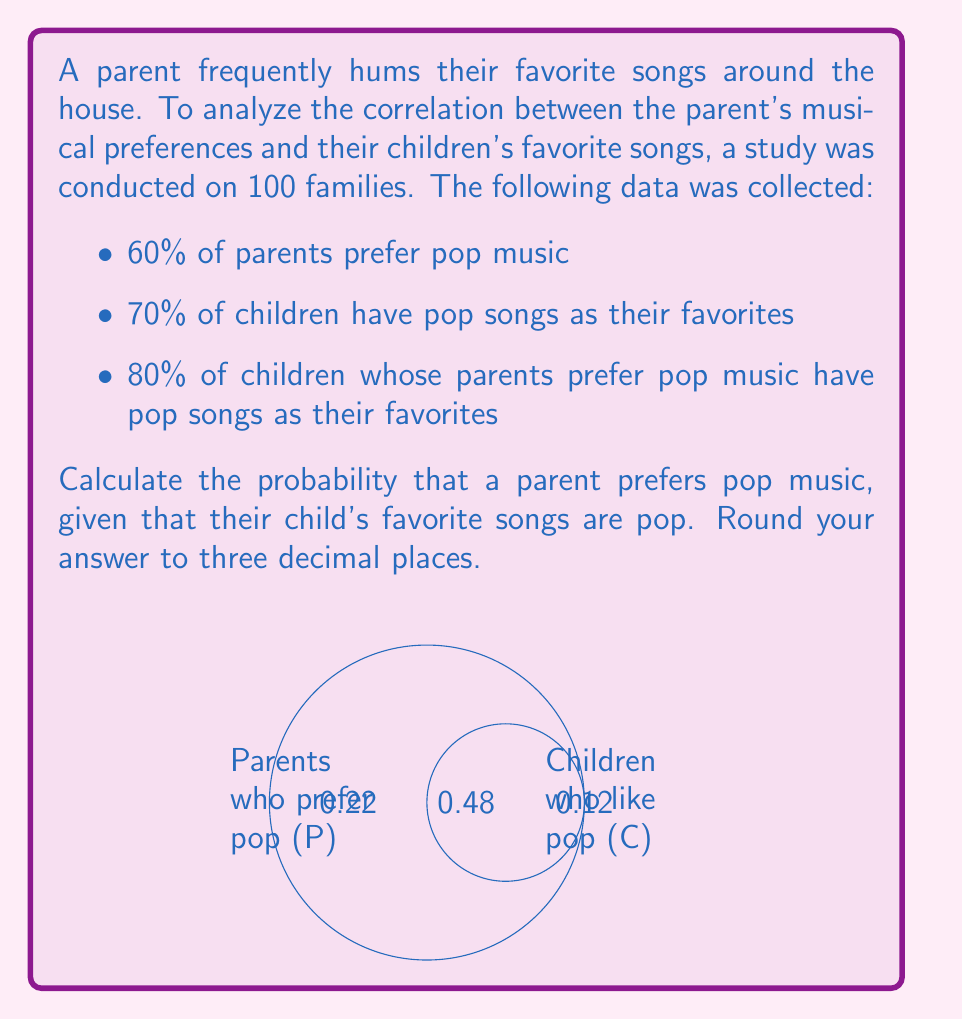Help me with this question. Let's approach this problem using Bayes' Theorem:

$$P(A|B) = \frac{P(B|A) \cdot P(A)}{P(B)}$$

Where:
A: Parent prefers pop music
B: Child's favorite songs are pop

Given:
$P(A) = 0.60$ (60% of parents prefer pop music)
$P(B) = 0.70$ (70% of children have pop songs as favorites)
$P(B|A) = 0.80$ (80% of children whose parents prefer pop have pop favorites)

Step 1: Calculate $P(B|A) \cdot P(A)$
$$P(B|A) \cdot P(A) = 0.80 \cdot 0.60 = 0.48$$

Step 2: Calculate $P(B)$ using the law of total probability
$$P(B) = P(B|A) \cdot P(A) + P(B|\text{not }A) \cdot P(\text{not }A)$$

We know $P(B|A) \cdot P(A) = 0.48$ from Step 1.
$P(\text{not }A) = 1 - P(A) = 1 - 0.60 = 0.40$
$P(B|\text{not }A) \cdot P(\text{not }A) = 0.70 - 0.48 = 0.22$

Step 3: Apply Bayes' Theorem
$$P(A|B) = \frac{0.48}{0.70} \approx 0.686$$

Step 4: Round to three decimal places
$$P(A|B) \approx 0.686$$
Answer: 0.686 